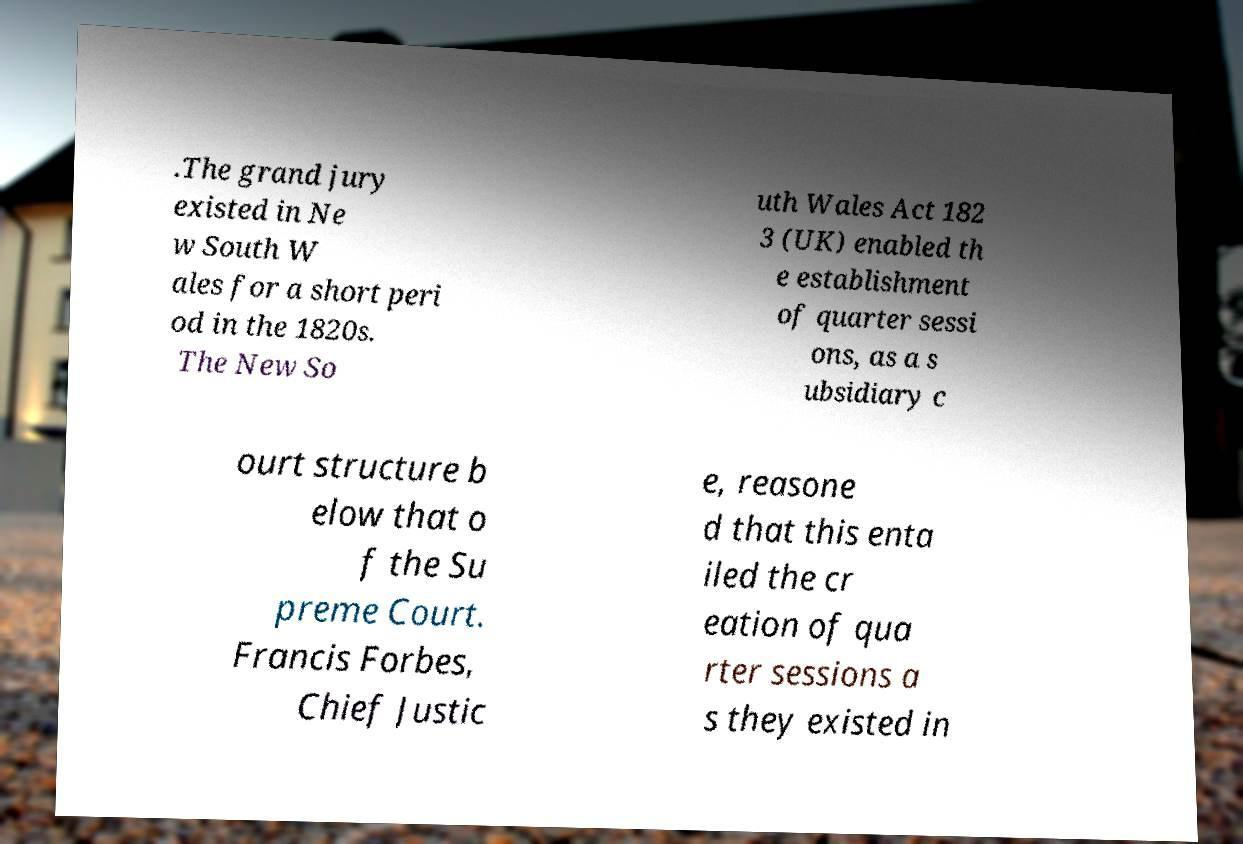Could you extract and type out the text from this image? .The grand jury existed in Ne w South W ales for a short peri od in the 1820s. The New So uth Wales Act 182 3 (UK) enabled th e establishment of quarter sessi ons, as a s ubsidiary c ourt structure b elow that o f the Su preme Court. Francis Forbes, Chief Justic e, reasone d that this enta iled the cr eation of qua rter sessions a s they existed in 